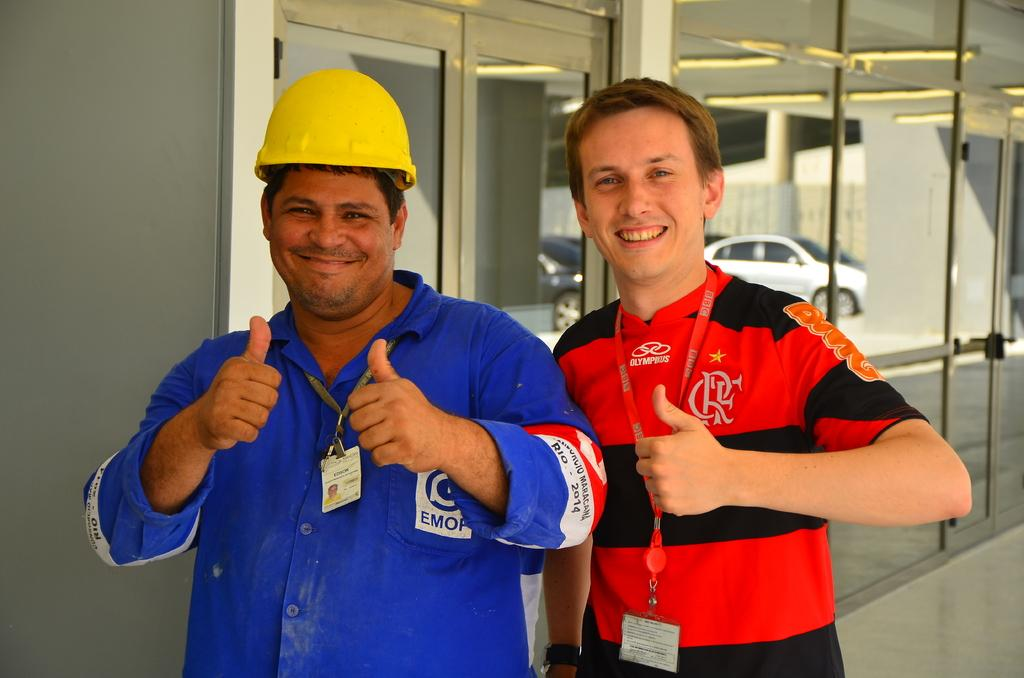How many people are present in the image? There are two people standing in the image. What can be seen behind the people? There is a door visible in the image. What objects are on the table or surface in the image? There are glasses in the image. What is visible through the glasses? Vehicles are parked on the ground, as seen through the glass. What type of knife is being used to cut the steam in the image? There is no knife or steam present in the image. What is the neck of the person doing in the image? There is no mention of a neck or any specific actions being performed by the people in the image. 